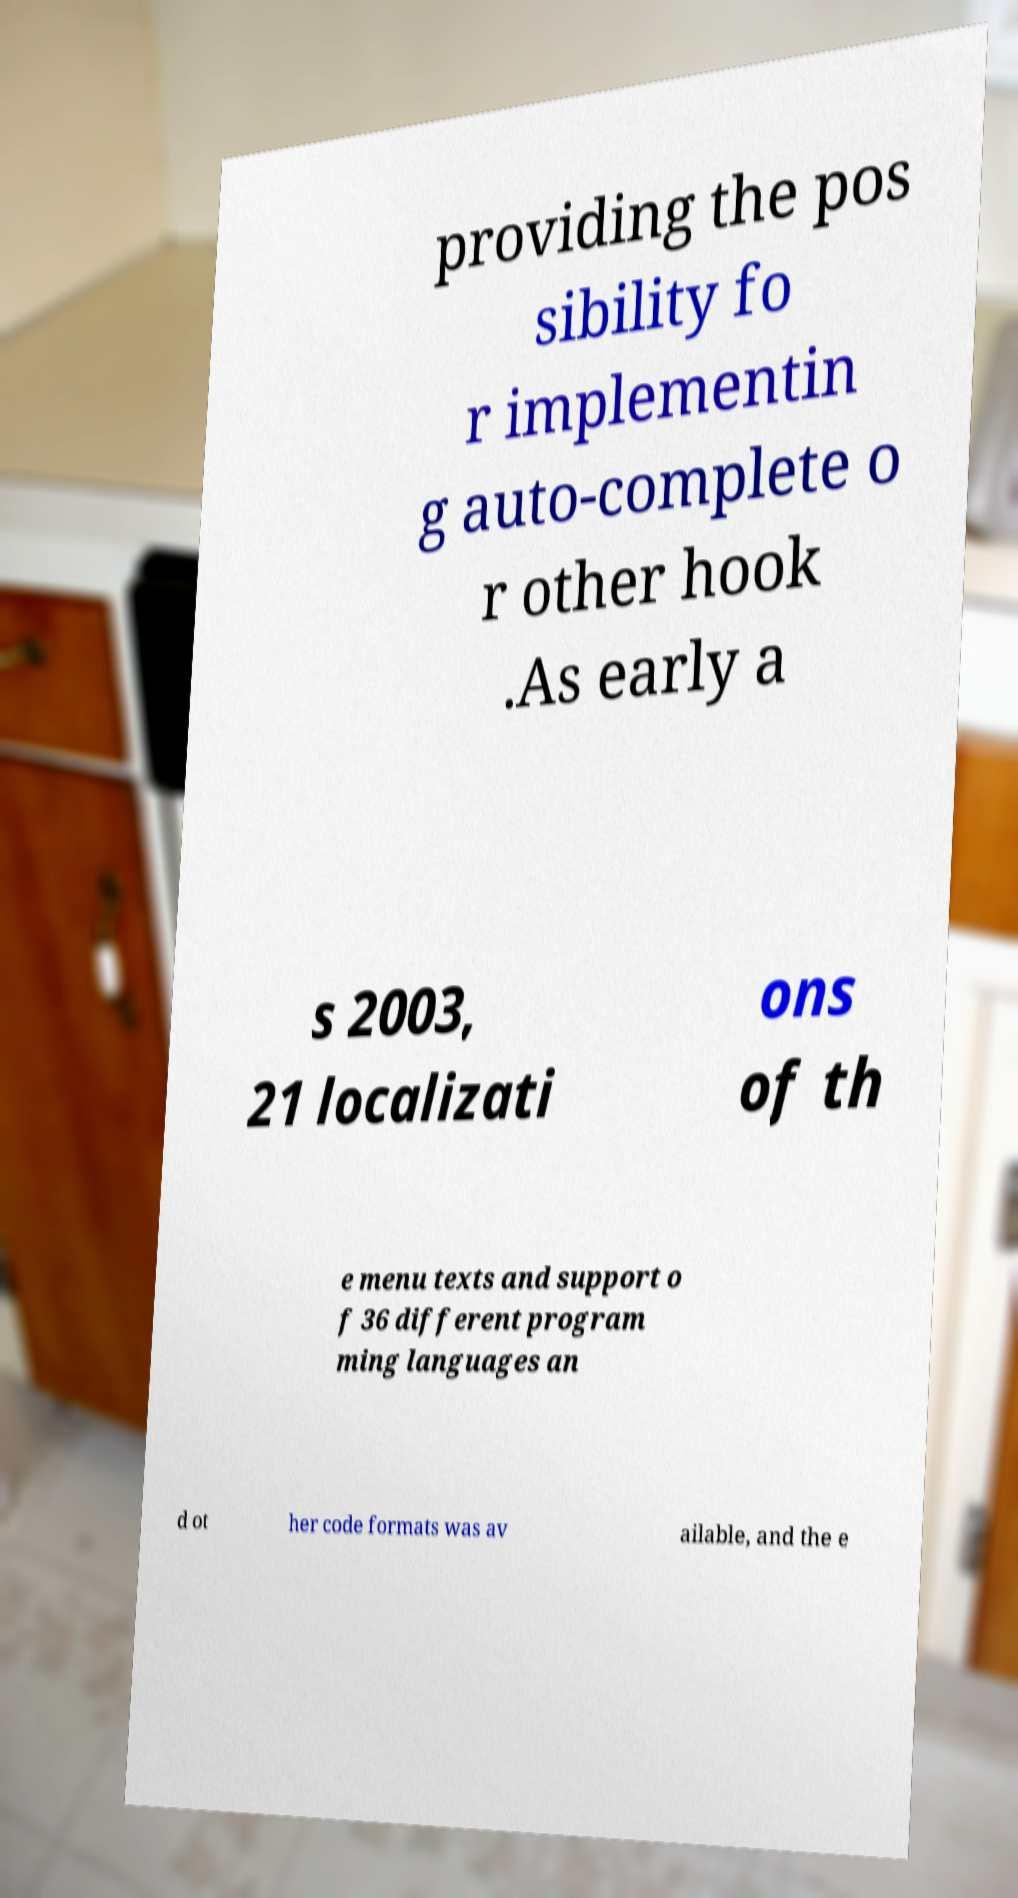Could you extract and type out the text from this image? providing the pos sibility fo r implementin g auto-complete o r other hook .As early a s 2003, 21 localizati ons of th e menu texts and support o f 36 different program ming languages an d ot her code formats was av ailable, and the e 